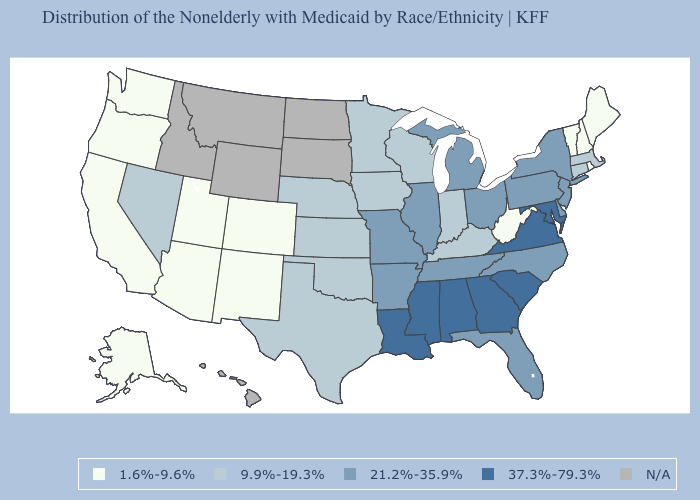What is the lowest value in states that border South Dakota?
Short answer required. 9.9%-19.3%. What is the value of California?
Short answer required. 1.6%-9.6%. Name the states that have a value in the range N/A?
Keep it brief. Hawaii, Idaho, Montana, North Dakota, South Dakota, Wyoming. Name the states that have a value in the range 1.6%-9.6%?
Concise answer only. Alaska, Arizona, California, Colorado, Maine, New Hampshire, New Mexico, Oregon, Rhode Island, Utah, Vermont, Washington, West Virginia. Among the states that border North Dakota , which have the highest value?
Keep it brief. Minnesota. Name the states that have a value in the range 1.6%-9.6%?
Concise answer only. Alaska, Arizona, California, Colorado, Maine, New Hampshire, New Mexico, Oregon, Rhode Island, Utah, Vermont, Washington, West Virginia. What is the lowest value in the USA?
Be succinct. 1.6%-9.6%. Does Ohio have the highest value in the MidWest?
Write a very short answer. Yes. Is the legend a continuous bar?
Keep it brief. No. Name the states that have a value in the range 21.2%-35.9%?
Answer briefly. Arkansas, Delaware, Florida, Illinois, Michigan, Missouri, New Jersey, New York, North Carolina, Ohio, Pennsylvania, Tennessee. What is the lowest value in the South?
Be succinct. 1.6%-9.6%. Which states have the lowest value in the USA?
Short answer required. Alaska, Arizona, California, Colorado, Maine, New Hampshire, New Mexico, Oregon, Rhode Island, Utah, Vermont, Washington, West Virginia. Among the states that border Oregon , does California have the highest value?
Answer briefly. No. Does Pennsylvania have the highest value in the USA?
Answer briefly. No. 